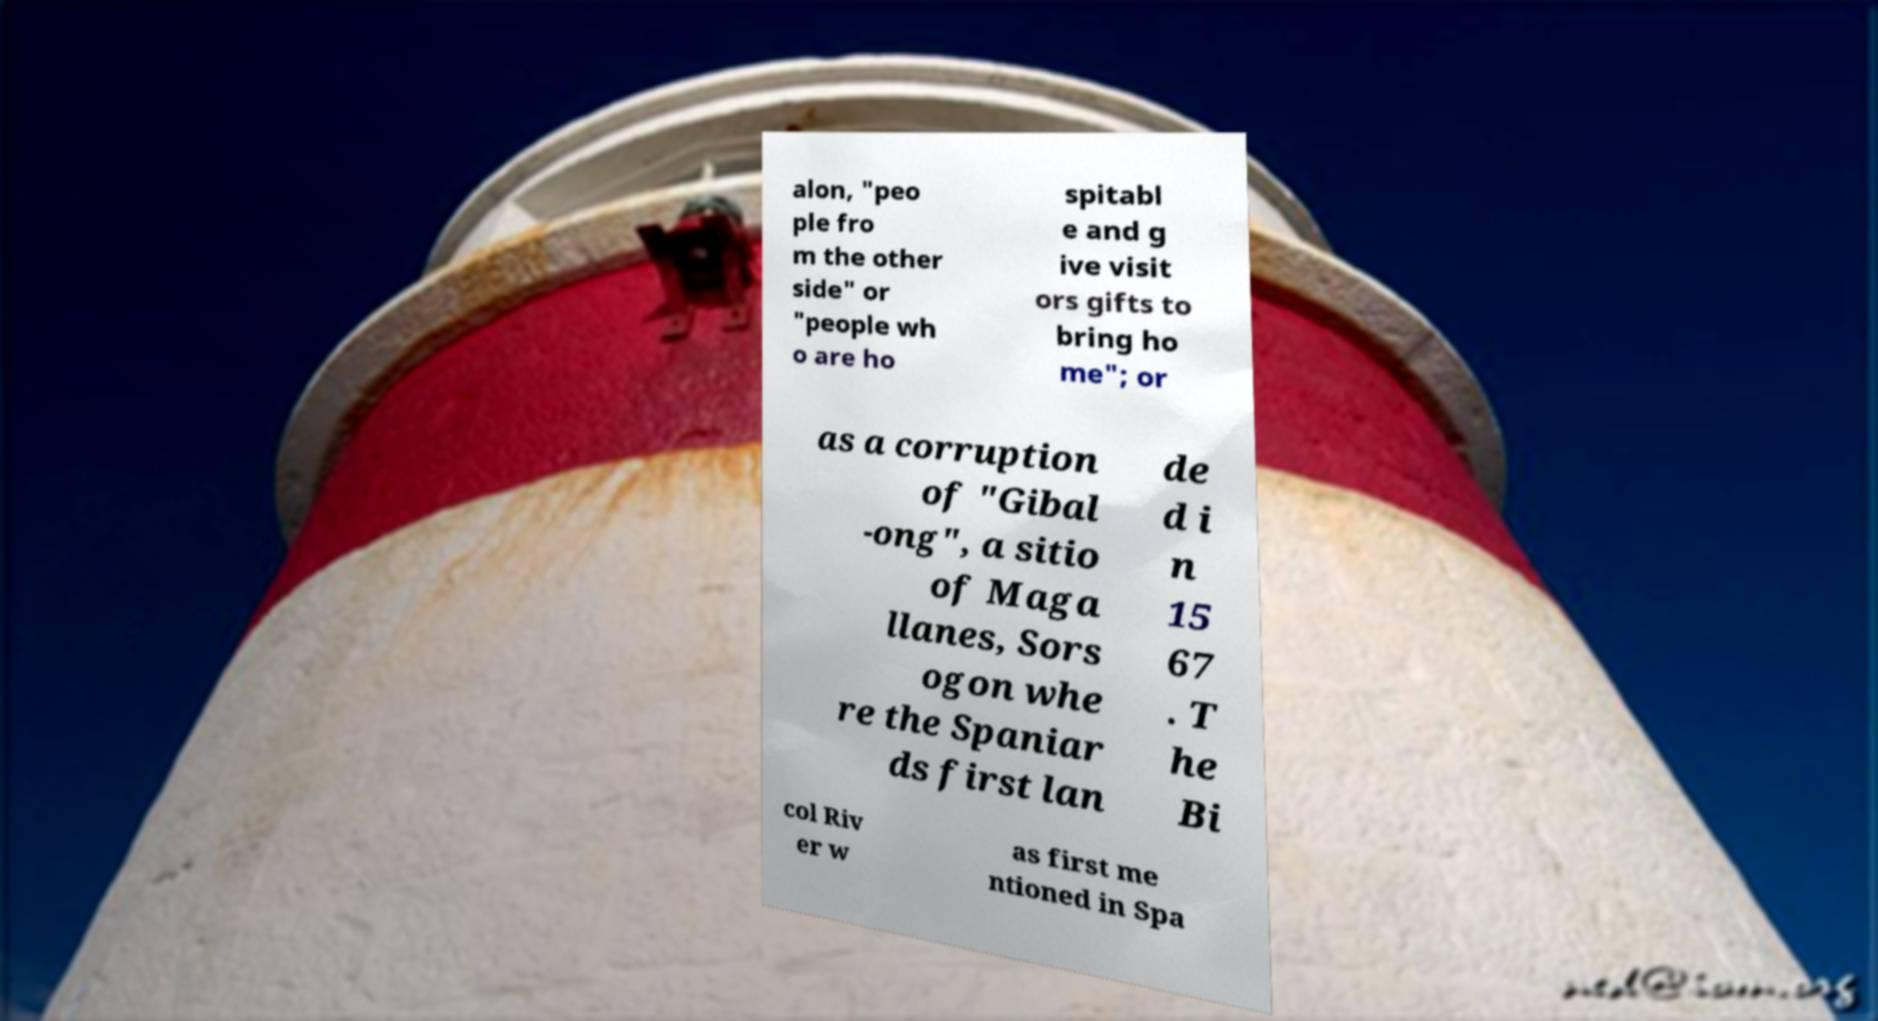I need the written content from this picture converted into text. Can you do that? alon, "peo ple fro m the other side" or "people wh o are ho spitabl e and g ive visit ors gifts to bring ho me"; or as a corruption of "Gibal -ong", a sitio of Maga llanes, Sors ogon whe re the Spaniar ds first lan de d i n 15 67 . T he Bi col Riv er w as first me ntioned in Spa 